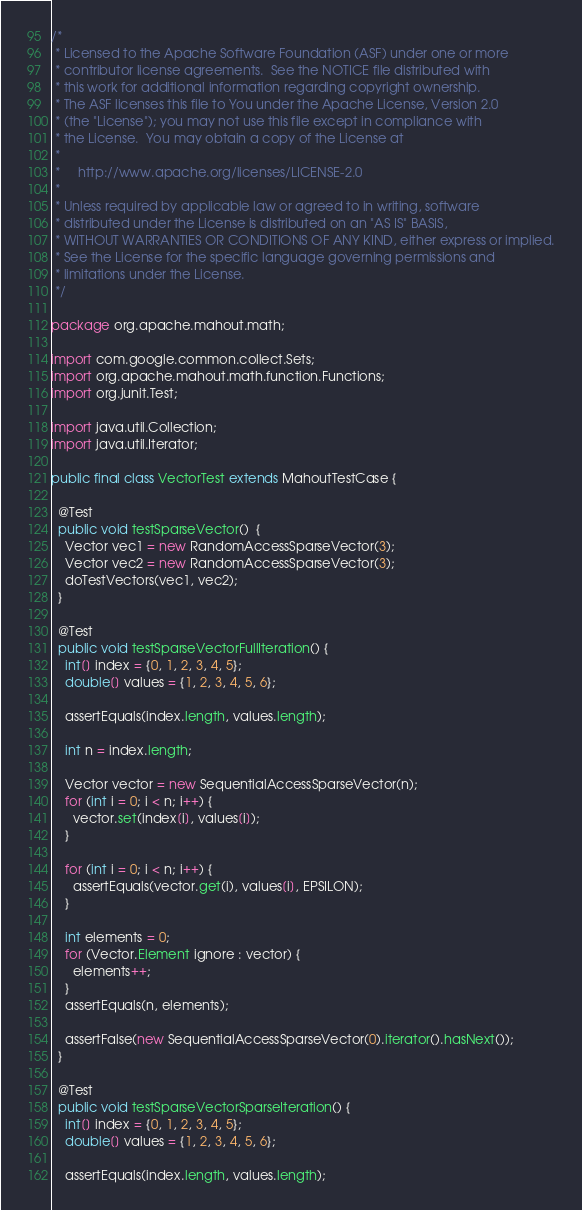<code> <loc_0><loc_0><loc_500><loc_500><_Java_>/*
 * Licensed to the Apache Software Foundation (ASF) under one or more
 * contributor license agreements.  See the NOTICE file distributed with
 * this work for additional information regarding copyright ownership.
 * The ASF licenses this file to You under the Apache License, Version 2.0
 * (the "License"); you may not use this file except in compliance with
 * the License.  You may obtain a copy of the License at
 *
 *     http://www.apache.org/licenses/LICENSE-2.0
 *
 * Unless required by applicable law or agreed to in writing, software
 * distributed under the License is distributed on an "AS IS" BASIS,
 * WITHOUT WARRANTIES OR CONDITIONS OF ANY KIND, either express or implied.
 * See the License for the specific language governing permissions and
 * limitations under the License.
 */

package org.apache.mahout.math;

import com.google.common.collect.Sets;
import org.apache.mahout.math.function.Functions;
import org.junit.Test;

import java.util.Collection;
import java.util.Iterator;

public final class VectorTest extends MahoutTestCase {

  @Test
  public void testSparseVector()  {
    Vector vec1 = new RandomAccessSparseVector(3);
    Vector vec2 = new RandomAccessSparseVector(3);
    doTestVectors(vec1, vec2);
  }

  @Test
  public void testSparseVectorFullIteration() {
    int[] index = {0, 1, 2, 3, 4, 5};
    double[] values = {1, 2, 3, 4, 5, 6};

    assertEquals(index.length, values.length);

    int n = index.length;

    Vector vector = new SequentialAccessSparseVector(n);
    for (int i = 0; i < n; i++) {
      vector.set(index[i], values[i]);
    }

    for (int i = 0; i < n; i++) {
      assertEquals(vector.get(i), values[i], EPSILON);
    }

    int elements = 0;
    for (Vector.Element ignore : vector) {
      elements++;
    }
    assertEquals(n, elements);

    assertFalse(new SequentialAccessSparseVector(0).iterator().hasNext());
  }

  @Test
  public void testSparseVectorSparseIteration() {
    int[] index = {0, 1, 2, 3, 4, 5};
    double[] values = {1, 2, 3, 4, 5, 6};

    assertEquals(index.length, values.length);
</code> 